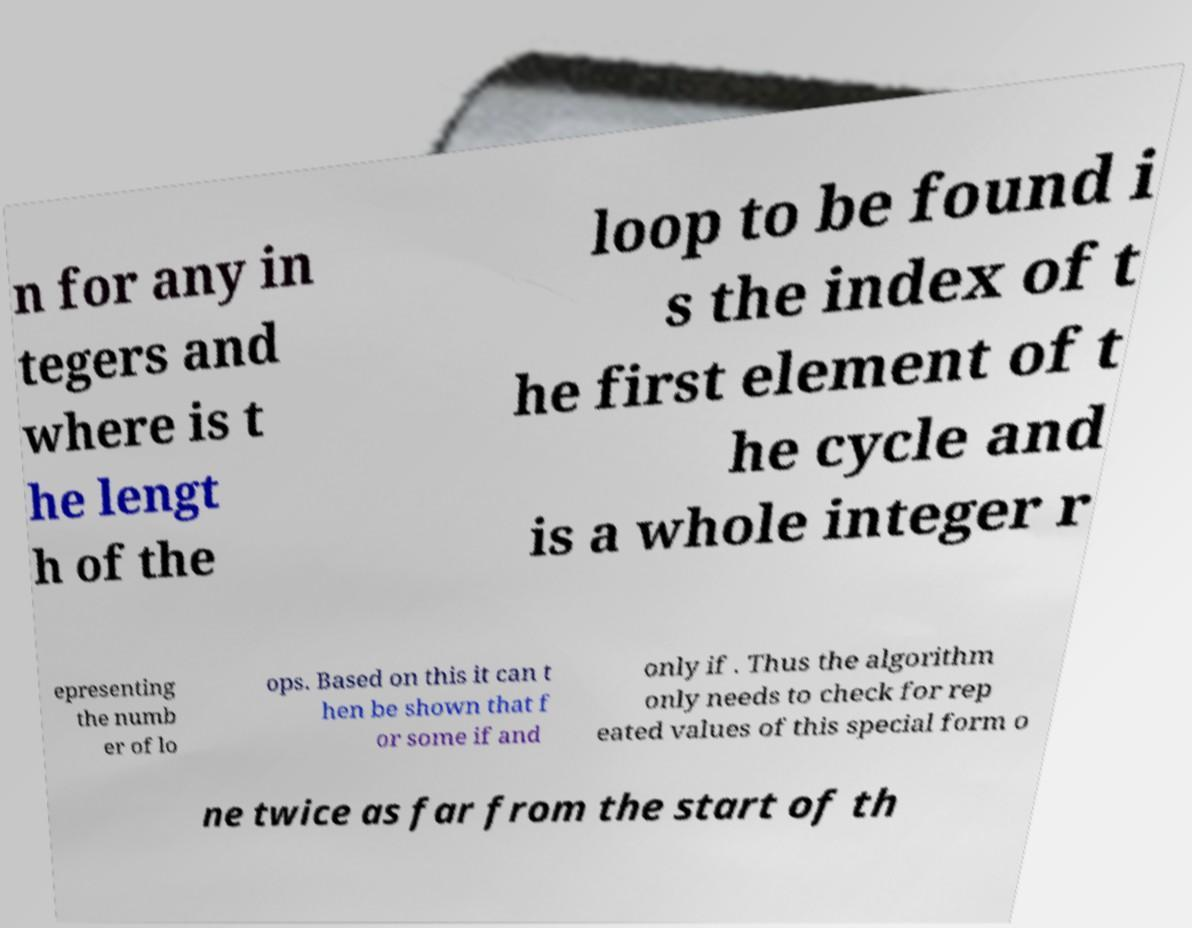Can you accurately transcribe the text from the provided image for me? n for any in tegers and where is t he lengt h of the loop to be found i s the index of t he first element of t he cycle and is a whole integer r epresenting the numb er of lo ops. Based on this it can t hen be shown that f or some if and only if . Thus the algorithm only needs to check for rep eated values of this special form o ne twice as far from the start of th 